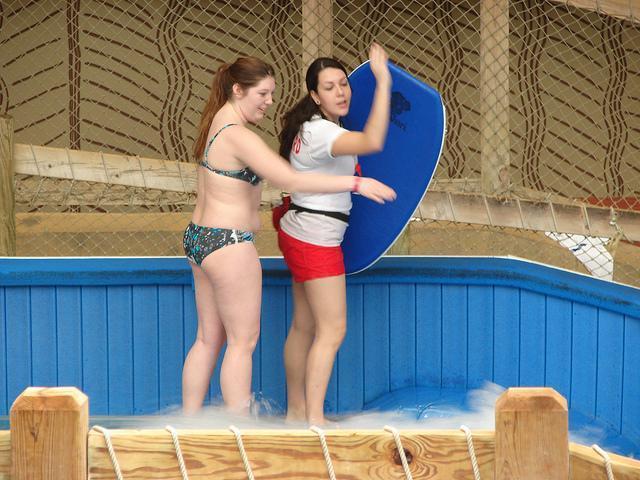How many people are there?
Give a very brief answer. 2. How many orange stripes are on the sail?
Give a very brief answer. 0. 